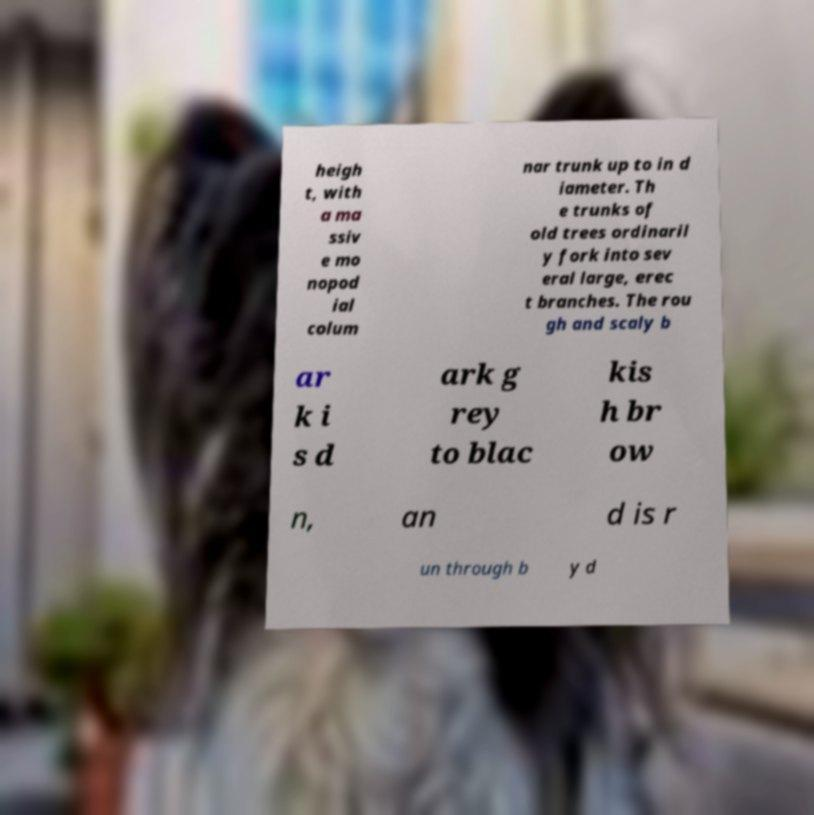Please read and relay the text visible in this image. What does it say? heigh t, with a ma ssiv e mo nopod ial colum nar trunk up to in d iameter. Th e trunks of old trees ordinaril y fork into sev eral large, erec t branches. The rou gh and scaly b ar k i s d ark g rey to blac kis h br ow n, an d is r un through b y d 